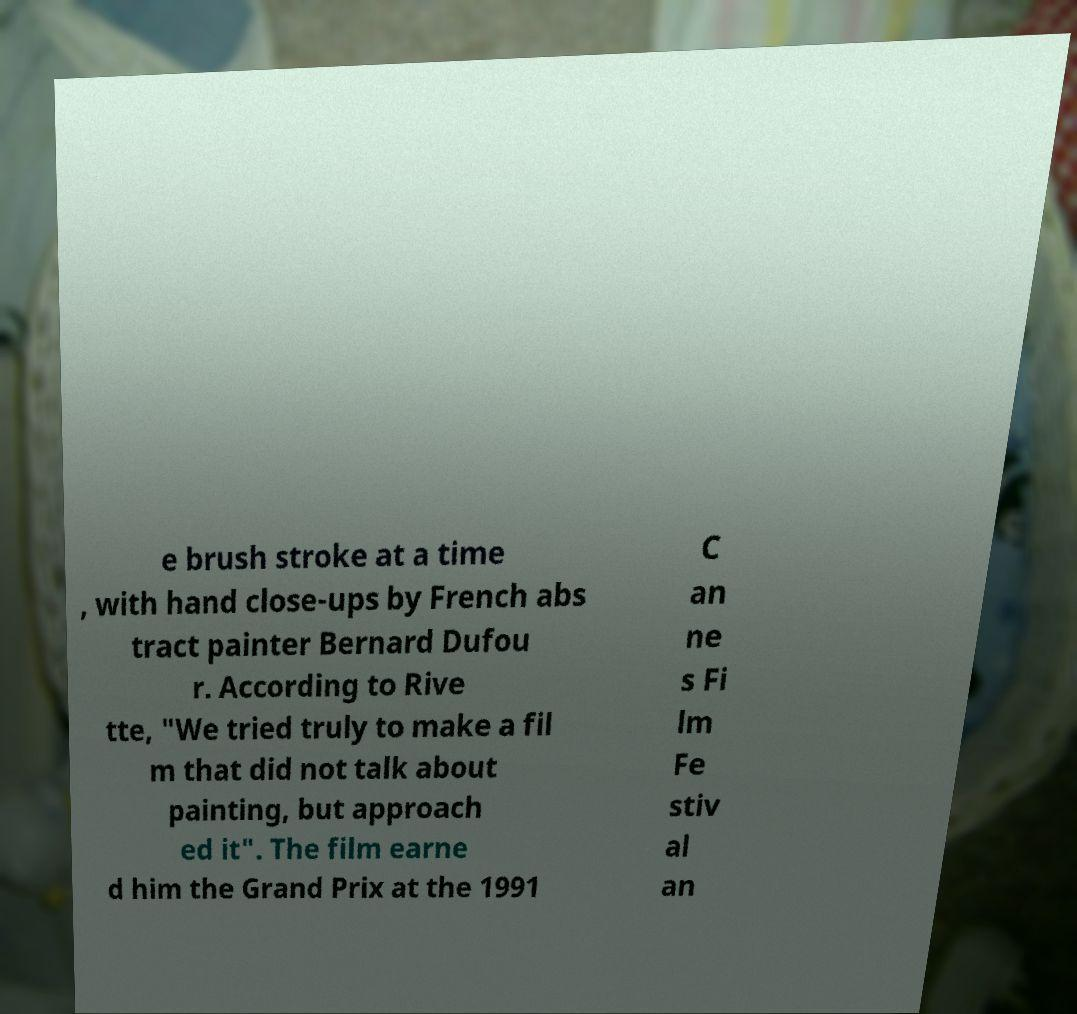There's text embedded in this image that I need extracted. Can you transcribe it verbatim? e brush stroke at a time , with hand close-ups by French abs tract painter Bernard Dufou r. According to Rive tte, "We tried truly to make a fil m that did not talk about painting, but approach ed it". The film earne d him the Grand Prix at the 1991 C an ne s Fi lm Fe stiv al an 